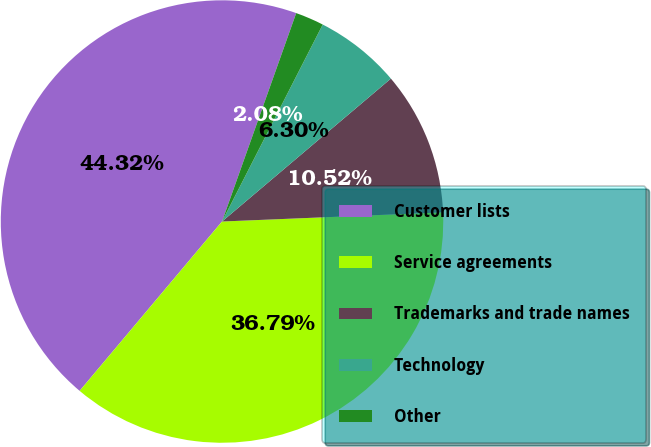Convert chart to OTSL. <chart><loc_0><loc_0><loc_500><loc_500><pie_chart><fcel>Customer lists<fcel>Service agreements<fcel>Trademarks and trade names<fcel>Technology<fcel>Other<nl><fcel>44.32%<fcel>36.79%<fcel>10.52%<fcel>6.3%<fcel>2.08%<nl></chart> 